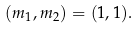<formula> <loc_0><loc_0><loc_500><loc_500>( m _ { 1 } , m _ { 2 } ) = ( 1 , 1 ) .</formula> 